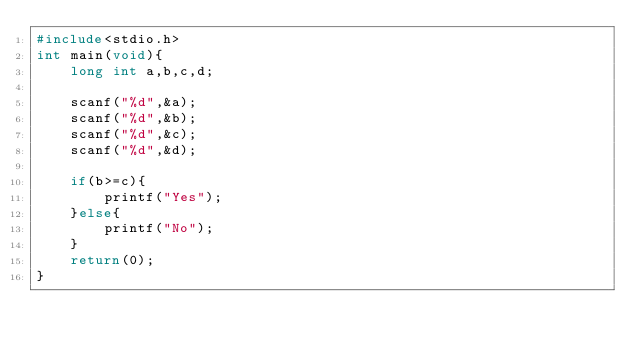Convert code to text. <code><loc_0><loc_0><loc_500><loc_500><_C_>#include<stdio.h>
int main(void){
	long int a,b,c,d;
	
	scanf("%d",&a);
	scanf("%d",&b);
	scanf("%d",&c);
	scanf("%d",&d);
	
	if(b>=c){
		printf("Yes");
	}else{
		printf("No");
	}
	return(0);
}</code> 